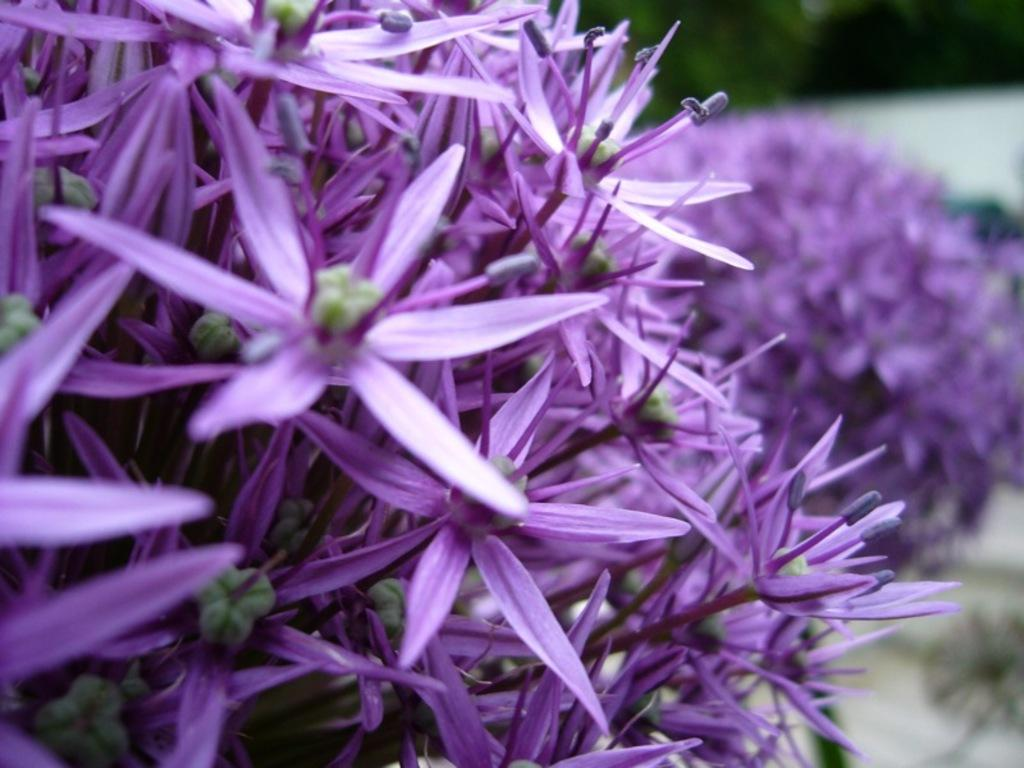What type of plants can be seen in the image? There are many flowers in the image. What color are the flowers? The flowers are purple. What can be seen in the background of the image? There are trees visible in the background of the image, although they are blurry. What story is being told in the image? There is no story being told in the image; it is a simple depiction of flowers and trees. Can you see any writing on the flowers in the image? There is no writing present on the flowers in the image. 